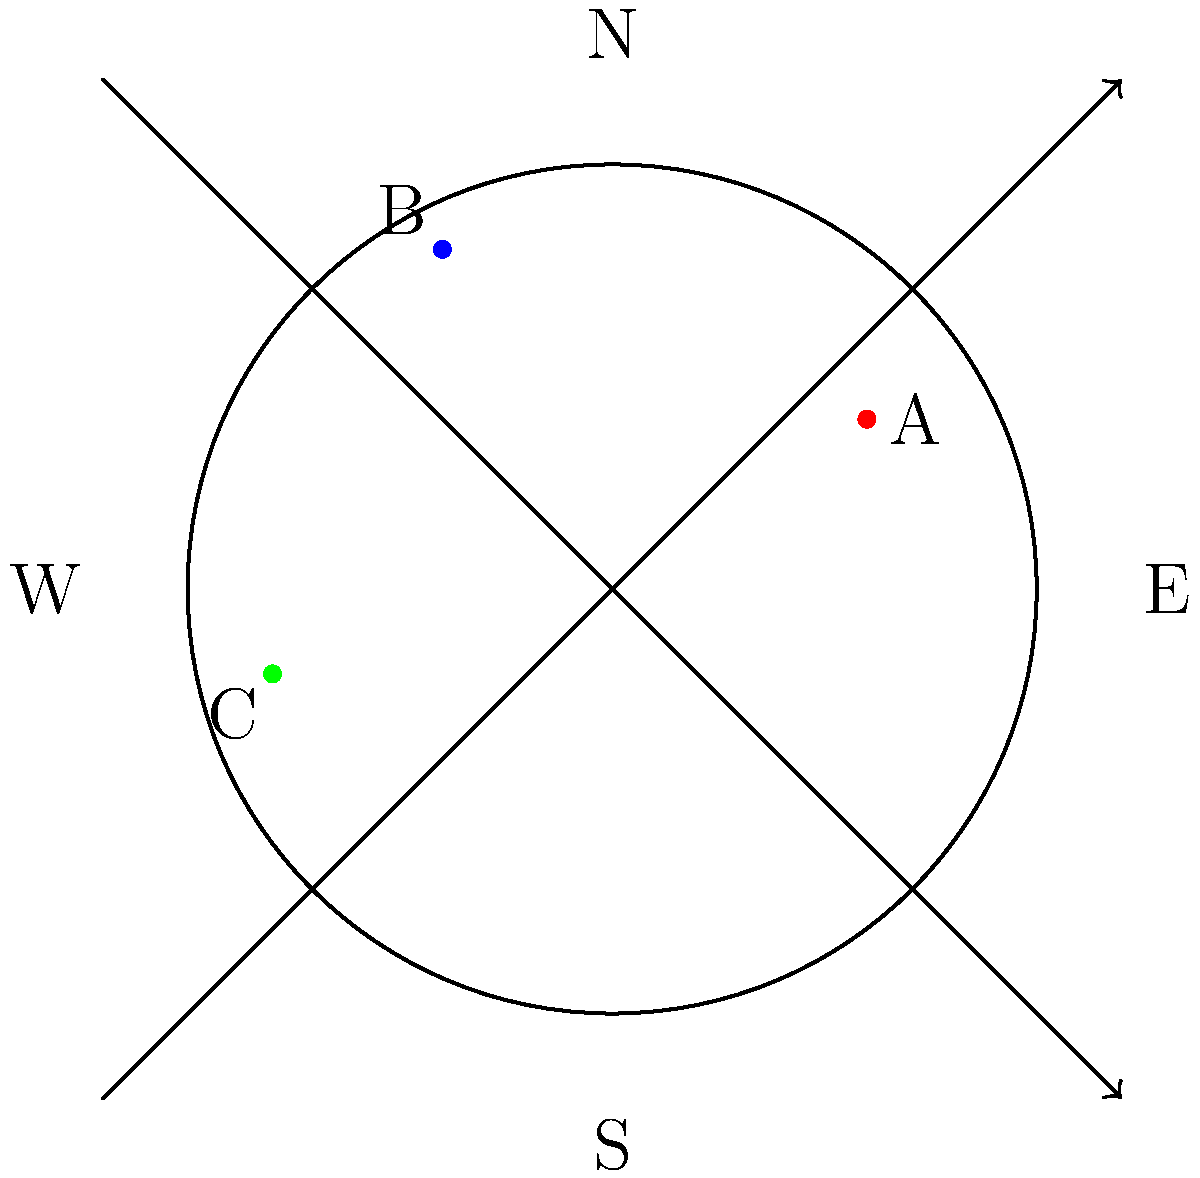In a circular séance room with a radius of 5 meters, you sense three distinct spirit energy sources (A, B, and C) at different locations. Given that North is at the top of the diagram, estimate the distance (in meters) and direction of spirit C from the center of the room. To estimate the distance and direction of spirit C from the center of the room, we need to follow these steps:

1. Analyze the position of spirit C on the diagram:
   - C is located in the bottom-left quadrant of the circle.
   - It appears to be about 4/5 of the way from the center to the edge of the circle.

2. Calculate the distance:
   - The room has a radius of 5 meters.
   - C is approximately 4/5 of the radius from the center.
   - Distance ≈ $5 \times \frac{4}{5} = 4$ meters

3. Determine the direction:
   - C is in the bottom-left quadrant, between West and South.
   - It appears to be closer to West than South.
   - The angle from West towards South is approximately 15-20 degrees.

4. Express the direction:
   - We can describe this as "Southwest" or more precisely as "15-20 degrees South of West"

Combining the distance and direction, we can estimate that spirit C is located approximately 4 meters Southwest (or 15-20 degrees South of West) from the center of the room.
Answer: 4 meters Southwest 